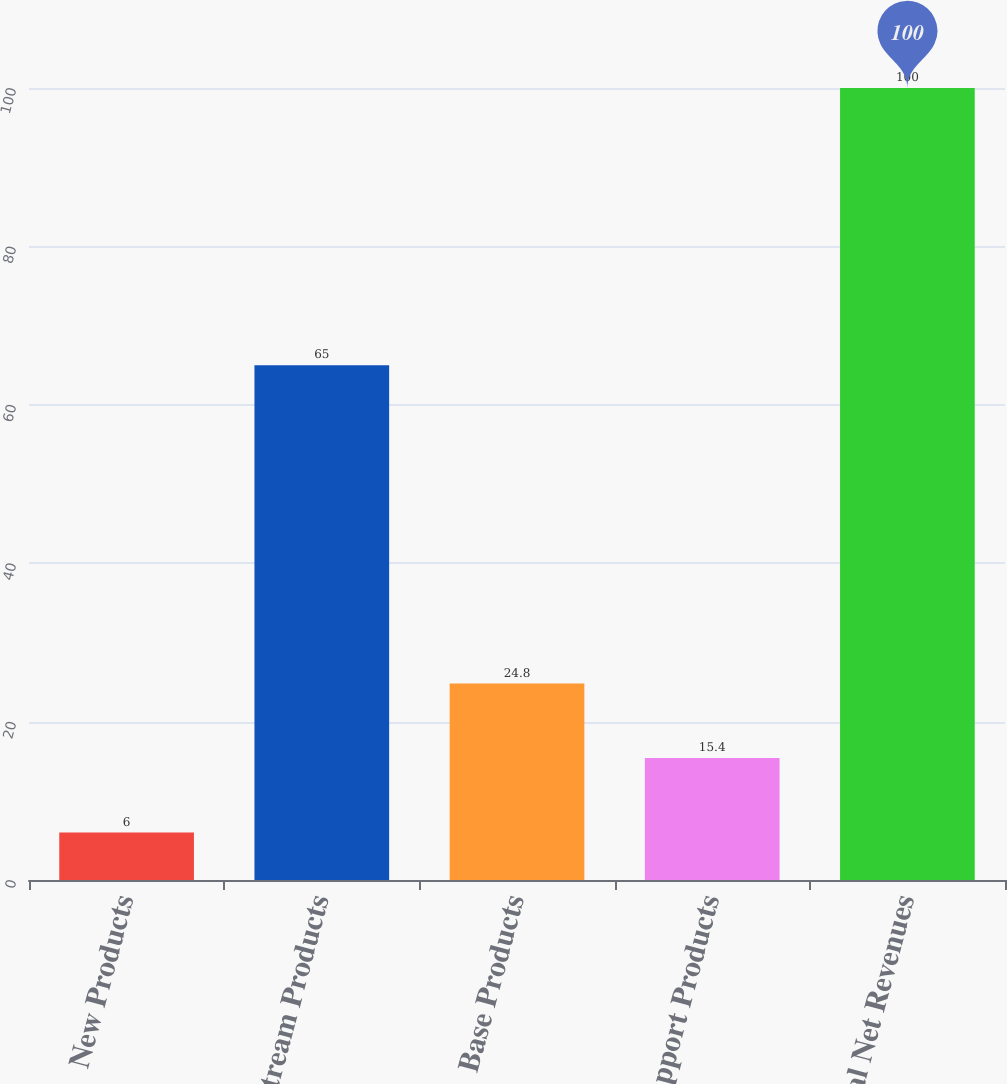<chart> <loc_0><loc_0><loc_500><loc_500><bar_chart><fcel>New Products<fcel>Mainstream Products<fcel>Base Products<fcel>Support Products<fcel>Total Net Revenues<nl><fcel>6<fcel>65<fcel>24.8<fcel>15.4<fcel>100<nl></chart> 